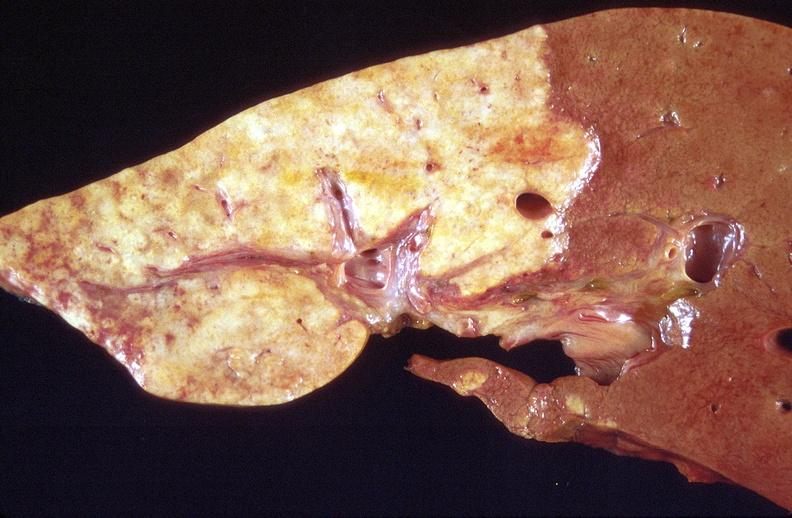s hepatobiliary present?
Answer the question using a single word or phrase. Yes 